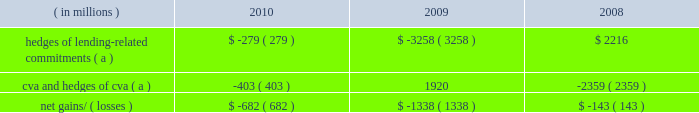Management 2019s discussion and analysis 128 jpmorgan chase & co./2010 annual report year ended december 31 .
( a ) these hedges do not qualify for hedge accounting under u.s .
Gaap .
Lending-related commitments jpmorgan chase uses lending-related financial instruments , such as commitments and guarantees , to meet the financing needs of its customers .
The contractual amount of these financial instruments represents the maximum possible credit risk should the counterpar- ties draw down on these commitments or the firm fulfills its obliga- tion under these guarantees , and should the counterparties subsequently fail to perform according to the terms of these con- tracts .
Wholesale lending-related commitments were $ 346.1 billion at december 31 , 2010 , compared with $ 347.2 billion at december 31 , 2009 .
The decrease reflected the january 1 , 2010 , adoption of accounting guidance related to vies .
Excluding the effect of the accounting guidance , lending-related commitments would have increased by $ 16.6 billion .
In the firm 2019s view , the total contractual amount of these wholesale lending-related commitments is not representative of the firm 2019s actual credit risk exposure or funding requirements .
In determining the amount of credit risk exposure the firm has to wholesale lend- ing-related commitments , which is used as the basis for allocating credit risk capital to these commitments , the firm has established a 201cloan-equivalent 201d amount for each commitment ; this amount represents the portion of the unused commitment or other contin- gent exposure that is expected , based on average portfolio histori- cal experience , to become drawn upon in an event of a default by an obligor .
The loan-equivalent amounts of the firm 2019s lending- related commitments were $ 189.9 billion and $ 179.8 billion as of december 31 , 2010 and 2009 , respectively .
Country exposure the firm 2019s wholesale portfolio includes country risk exposures to both developed and emerging markets .
The firm seeks to diversify its country exposures , including its credit-related lending , trading and investment activities , whether cross-border or locally funded .
Country exposure under the firm 2019s internal risk management ap- proach is reported based on the country where the assets of the obligor , counterparty or guarantor are located .
Exposure amounts , including resale agreements , are adjusted for collateral and for credit enhancements ( e.g. , guarantees and letters of credit ) pro- vided by third parties ; outstandings supported by a guarantor located outside the country or backed by collateral held outside the country are assigned to the country of the enhancement provider .
In addition , the effect of credit derivative hedges and other short credit or equity trading positions are taken into consideration .
Total exposure measures include activity with both government and private-sector entities in a country .
The firm also reports country exposure for regulatory purposes following ffiec guidelines , which are different from the firm 2019s internal risk management approach for measuring country expo- sure .
For additional information on the ffiec exposures , see cross- border outstandings on page 314 of this annual report .
Several european countries , including greece , portugal , spain , italy and ireland , have been subject to credit deterioration due to weak- nesses in their economic and fiscal situations .
The firm is closely monitoring its exposures to these five countries .
Aggregate net exposures to these five countries as measured under the firm 2019s internal approach was less than $ 15.0 billion at december 31 , 2010 , with no country representing a majority of the exposure .
Sovereign exposure in all five countries represented less than half the aggregate net exposure .
The firm currently believes its exposure to these five countries is modest relative to the firm 2019s overall risk expo- sures and is manageable given the size and types of exposures to each of the countries and the diversification of the aggregate expo- sure .
The firm continues to conduct business and support client activity in these countries and , therefore , the firm 2019s aggregate net exposures may vary over time .
In addition , the net exposures may be impacted by changes in market conditions , and the effects of interest rates and credit spreads on market valuations .
As part of its ongoing country risk management process , the firm monitors exposure to emerging market countries , and utilizes country stress tests to measure and manage the risk of extreme loss associated with a sovereign crisis .
There is no common definition of emerging markets , but the firm generally includes in its definition those countries whose sovereign debt ratings are equivalent to 201ca+ 201d or lower .
The table below presents the firm 2019s exposure to its top 10 emerging markets countries based on its internal measure- ment approach .
The selection of countries is based solely on the firm 2019s largest total exposures by country and does not represent its view of any actual or potentially adverse credit conditions. .
What was the percent of the net gains and losses from cva and hedges of cva ( a )? 
Computations: (403 / 682)
Answer: 0.59091. 